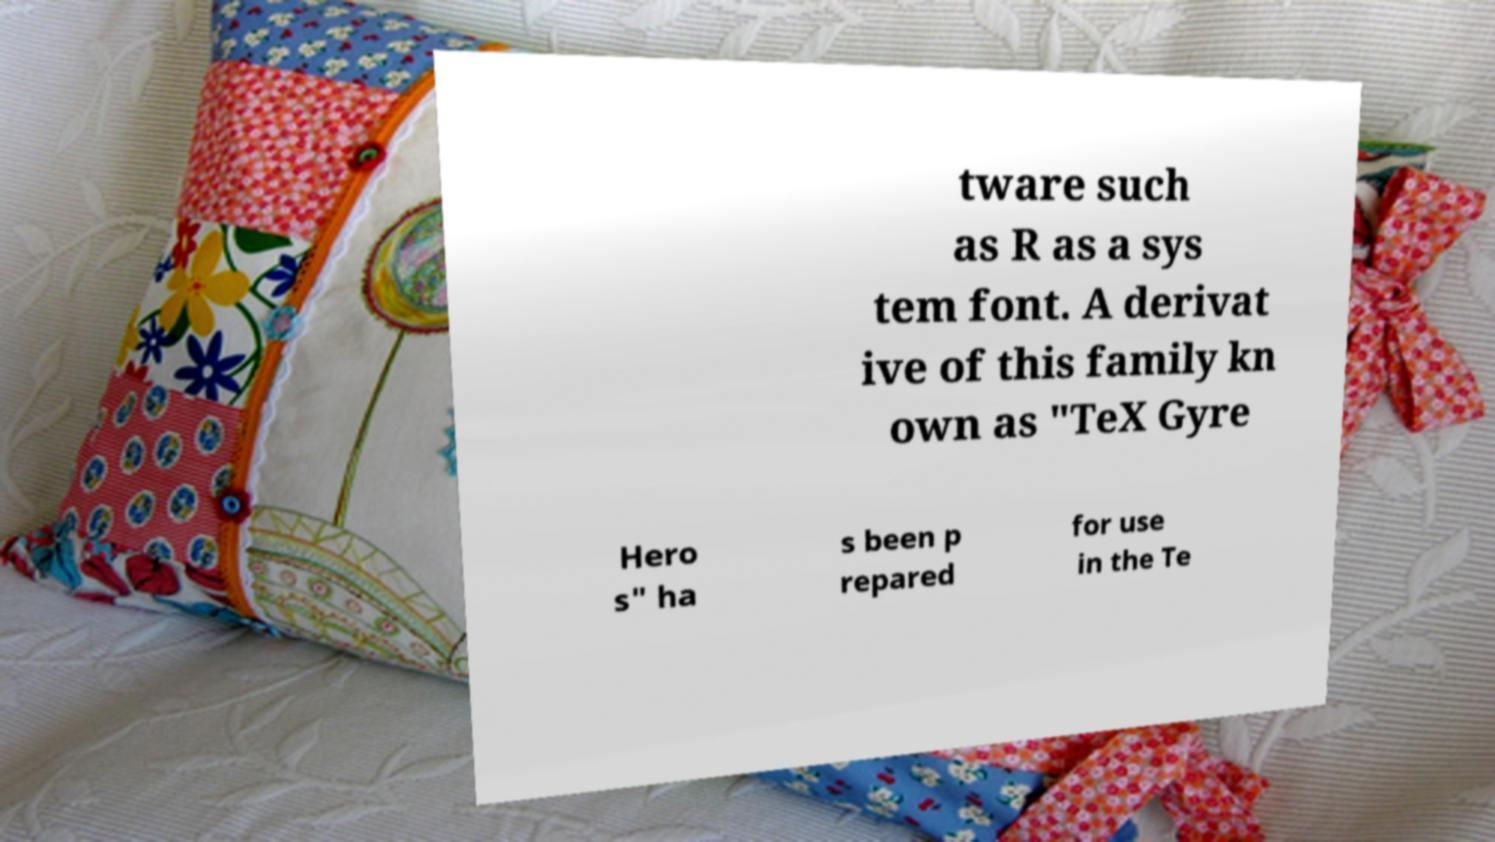Can you read and provide the text displayed in the image?This photo seems to have some interesting text. Can you extract and type it out for me? tware such as R as a sys tem font. A derivat ive of this family kn own as "TeX Gyre Hero s" ha s been p repared for use in the Te 